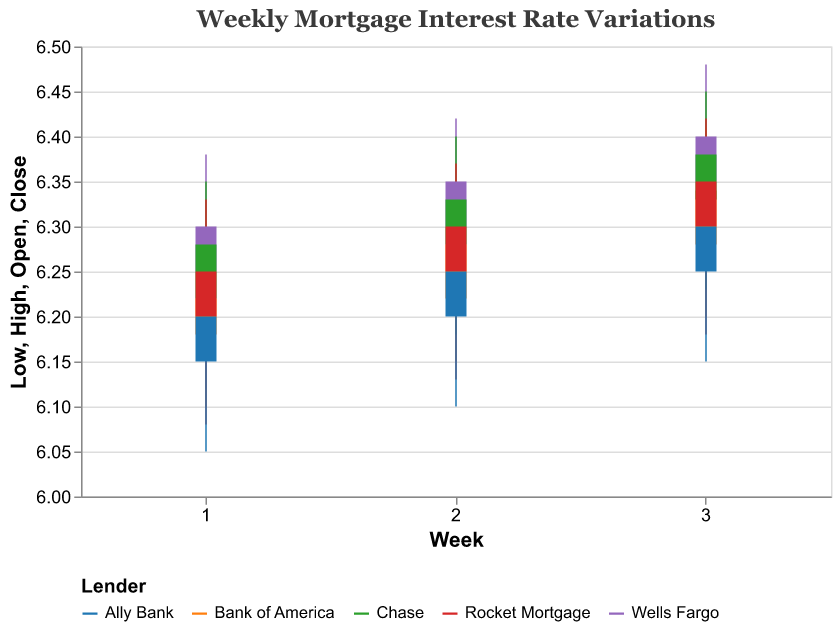What is the title of the figure? The title is usually located at the top of the figure and provides an overall description of what the figure represents. Here, it states "Weekly Mortgage Interest Rate Variations".
Answer: Weekly Mortgage Interest Rate Variations Which lender had the highest closing rate in Week 3? Observing the "Close" values in Week 3 from the chart, the highest closing rate was provided by Wells Fargo at 6.40%.
Answer: Wells Fargo What is the average opening rate for Chase over the three weeks? Add the opening rates for Chase in Week 1, Week 2, and Week 3, then divide by the number of observations. Calculation: (6.22 + 6.28 + 6.33) / 3 = 6.277.
Answer: 6.28 Which lender had the lowest low rate in Week 1? By looking at the "Low" values in Week 1 from the chart, Ally Bank had the lowest low rate, which was 6.05%.
Answer: Ally Bank Compare the high rates of Wells Fargo and Chase in Week 2. Which is higher and by how much? Subtract the high rate of Chase from the high rate of Wells Fargo in Week 2. Wells Fargo: 6.42% and Chase: 6.40%. Calculation: 6.42 - 6.40 = 0.02%.
Answer: Wells Fargo by 0.02% What is the trend in the closing rates for Rocket Mortgage over the three weeks? The closing rates for Rocket Mortgage over the weeks are: Week 1 (6.25%), Week 2 (6.30%), Week 3 (6.35%). The trend shows a steady increase.
Answer: Increasing Find the lender with the highest volatility (difference between highest and lowest rate) in Week 1. Calculate the differences for each lender in Week 1 and compare: - Wells Fargo: 6.38 - 6.12 = 0.26 - Bank of America: 6.29 - 6.10 = 0.19 - Chase: 6.35 - 6.15 = 0.20 - Rocket Mortgage: 6.33 - 6.08 = 0.25 - Ally Bank: 6.27 - 6.05 = 0.22 Wells Fargo has the highest volatility at 0.26.
Answer: Wells Fargo What is the highest opening rate in Week 3 among all lenders? Look for the maximum "Open" value for Week 3 across lenders: Wells Fargo (6.35), Bank of America (6.28), Chase (6.33), Rocket Mortgage (6.30), Ally Bank (6.25). The highest is Wells Fargo at 6.35%.
Answer: 6.35% Compare the close rates from Week 1 and Week 2 for Ally Bank. Are they increasing, decreasing, or constant? Check the "Close" values for Ally Bank: Week 1 (6.20), Week 2 (6.25). From Week 1 to Week 2, the rates are increasing.
Answer: Increasing Which lender's highest rate in Week 2 is equal to Wells Fargo’s closing rate in Week 3? Check Wells Fargo's closing rate in Week 3: 6.40%. Then find which lender's highest rate in Week 2 matches this: Chase had a high rate of 6.40% in Week 2.
Answer: Chase 